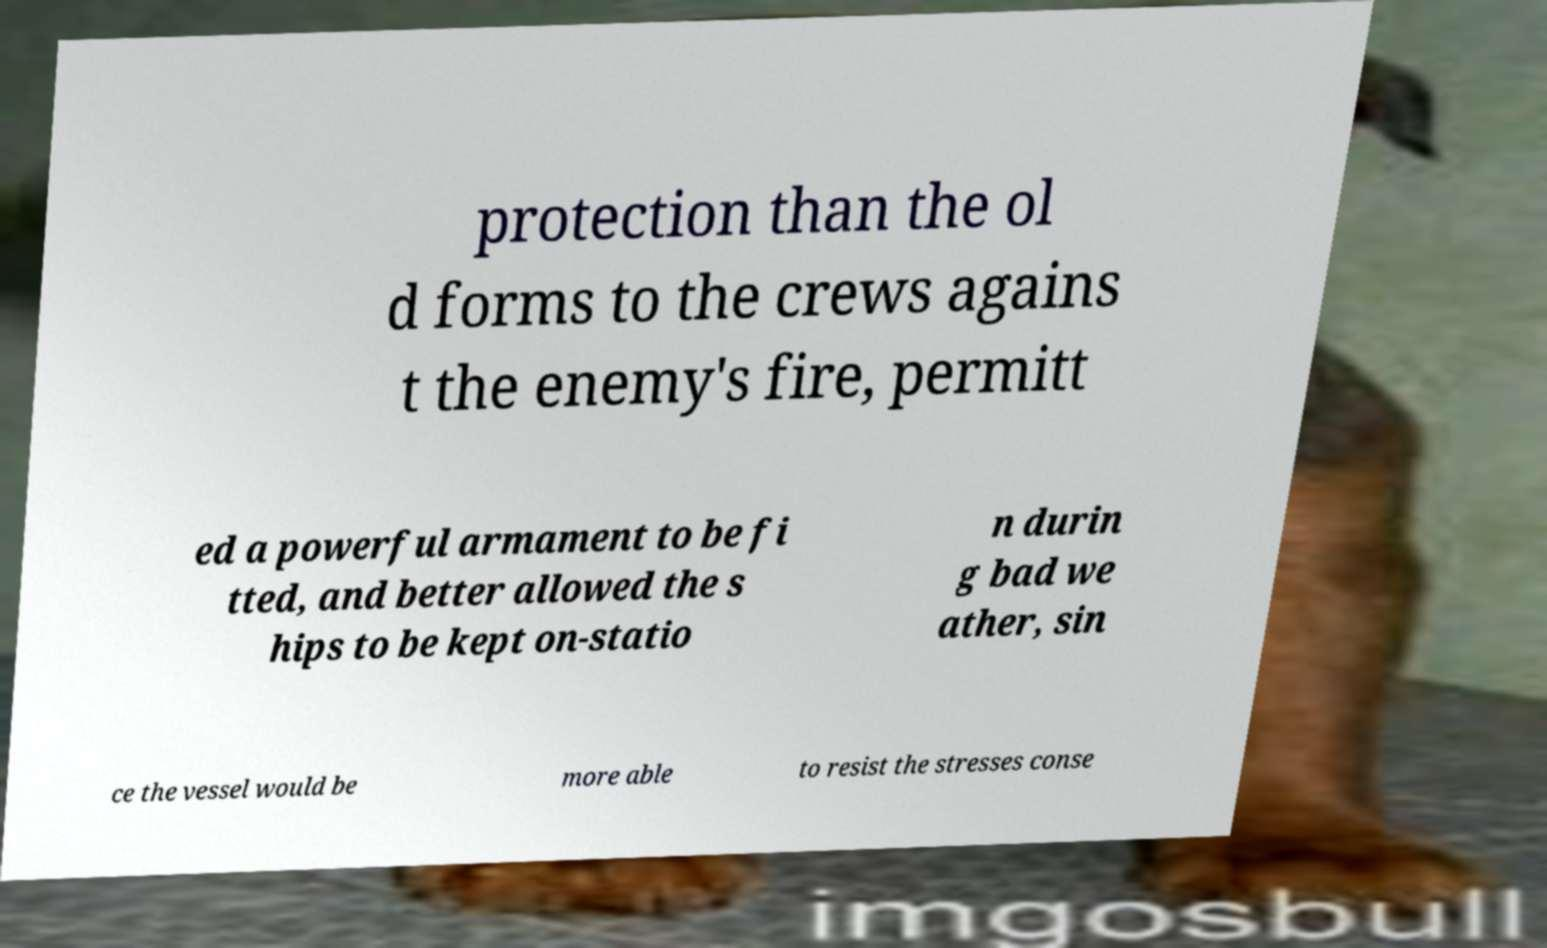There's text embedded in this image that I need extracted. Can you transcribe it verbatim? protection than the ol d forms to the crews agains t the enemy's fire, permitt ed a powerful armament to be fi tted, and better allowed the s hips to be kept on-statio n durin g bad we ather, sin ce the vessel would be more able to resist the stresses conse 